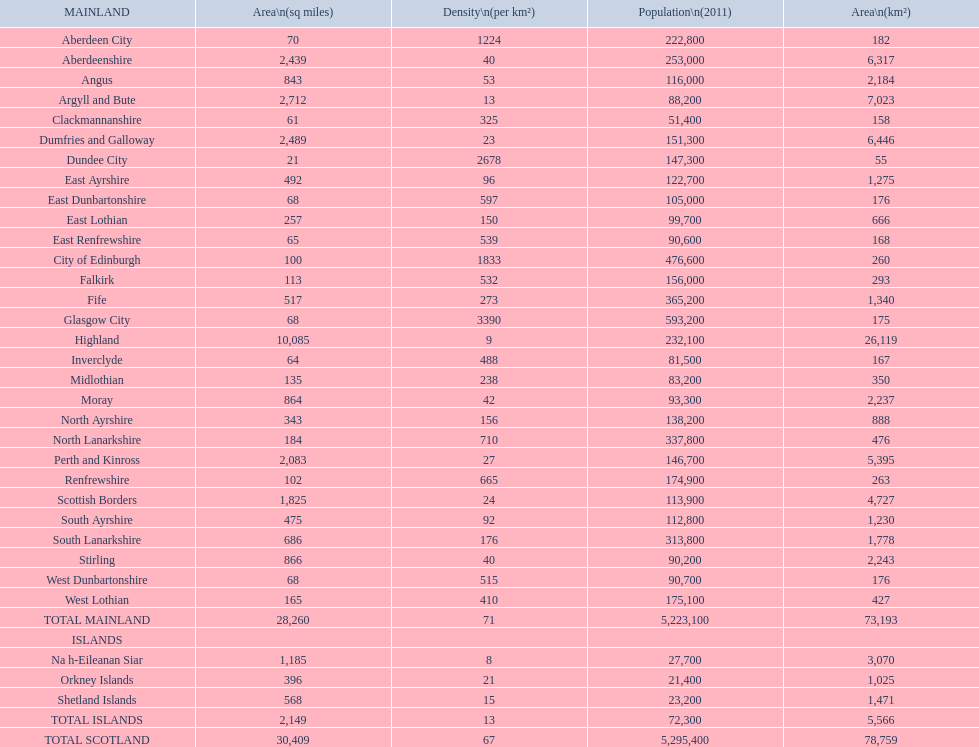What number of mainlands have populations under 100,000? 9. 